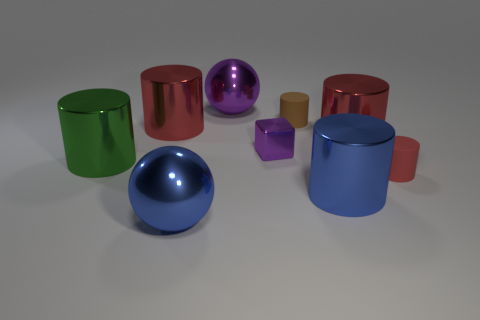How many red cylinders must be subtracted to get 2 red cylinders? 1 Subtract all cyan spheres. How many red cylinders are left? 3 Subtract all small cylinders. How many cylinders are left? 4 Add 1 purple blocks. How many objects exist? 10 Subtract all spheres. How many objects are left? 7 Subtract all purple balls. How many balls are left? 1 Subtract all blue balls. Subtract all red cylinders. How many balls are left? 1 Subtract all big red cylinders. Subtract all tiny brown rubber cylinders. How many objects are left? 6 Add 6 matte cylinders. How many matte cylinders are left? 8 Add 1 blue shiny cylinders. How many blue shiny cylinders exist? 2 